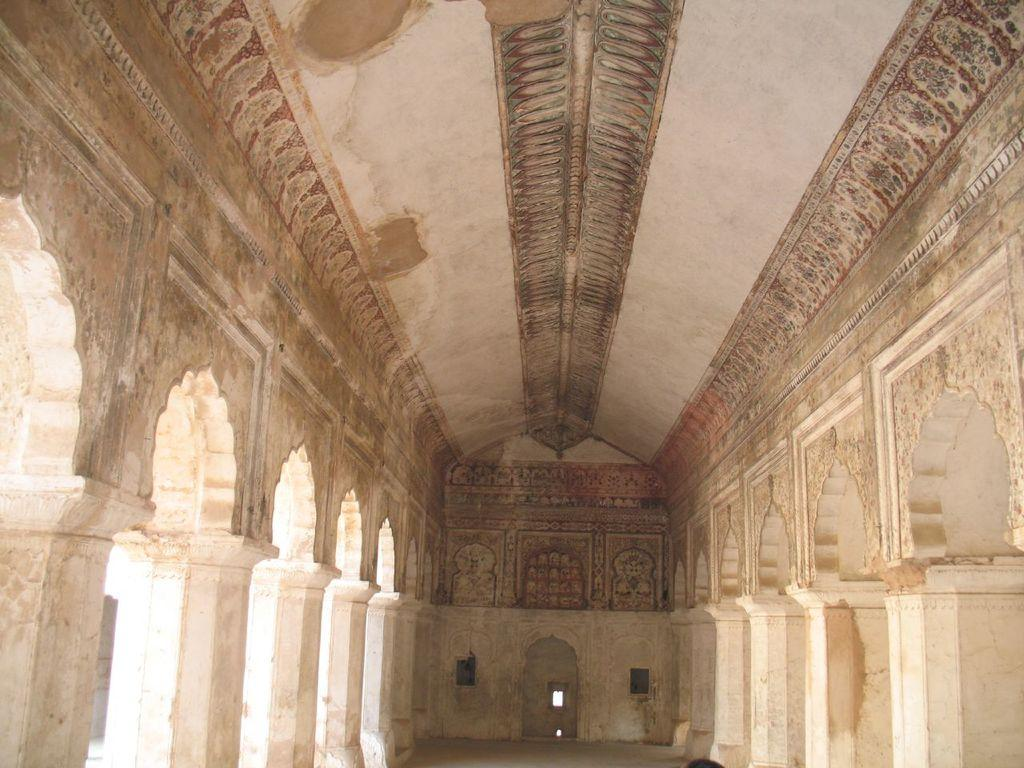What type of structure can be seen in the image? There is a wall in the image. What are the notable features of the wall? The wall has pillars. Are there any additional architectural elements visible in the image? Yes, there are arches to the left and right of the wall. How many spiders can be seen crawling on the wall in the image? There are no spiders visible in the image. What is the increase in the number of arches in the image? The image does not show any changes or increases in the number of arches; there are only two arches present. 